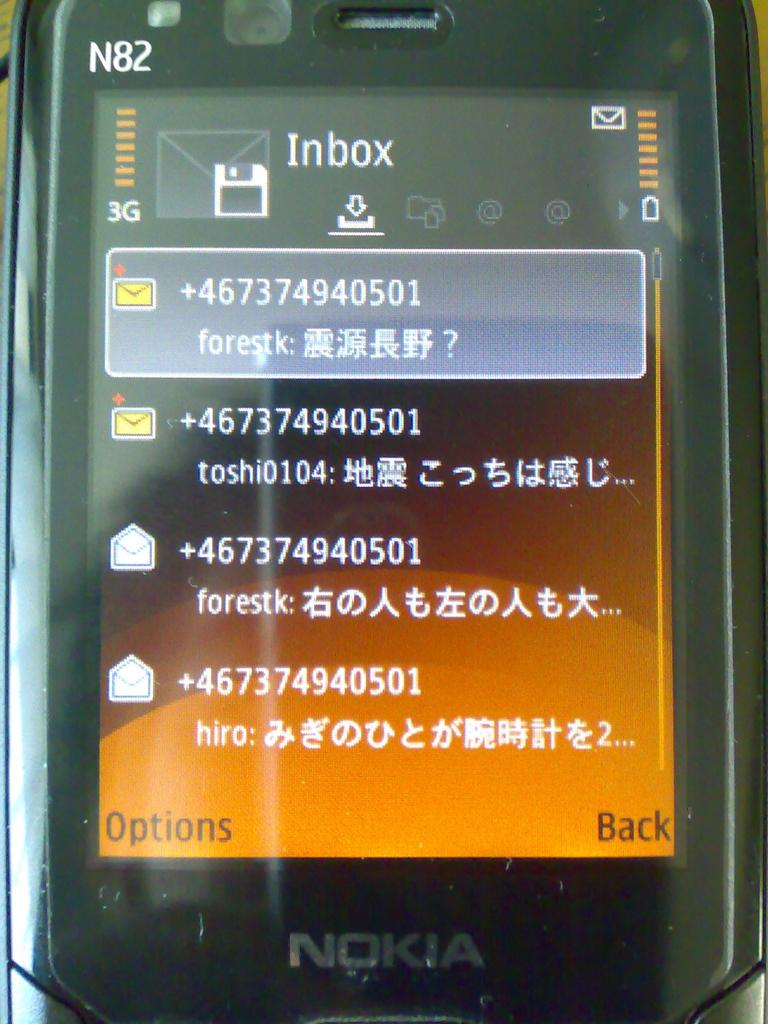<image>
Share a concise interpretation of the image provided. A black Nokia phone displays messages in the inbox. 